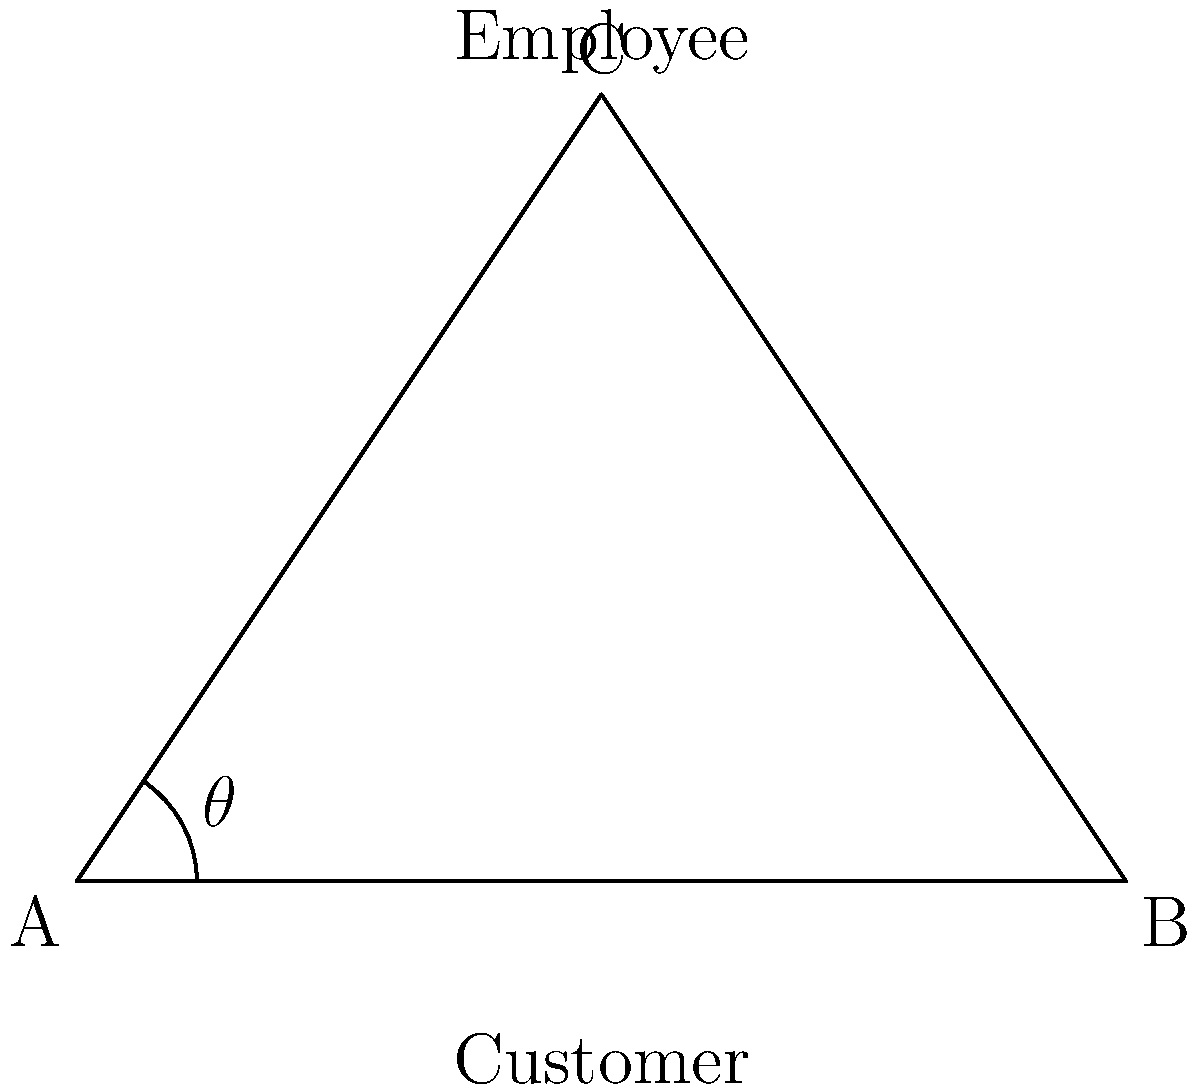In a customer interaction scenario, the angle of eye contact ($\theta$) between an employee and a customer is represented in the diagram. If the distance between the customer's eyes (AB) is 6 cm and the height of the employee's eyes from the customer's eye level (AC) is 9 cm, what is the angle of eye contact ($\theta$) to the nearest degree? To find the angle of eye contact ($\theta$), we can use the trigonometric function tangent. Let's approach this step-by-step:

1) In the right-angled triangle ABC, we know:
   - AB (opposite to $\theta$) = 6 cm
   - AC (adjacent to $\theta$) = 9 cm

2) The tangent of an angle is defined as the ratio of the opposite side to the adjacent side:

   $\tan(\theta) = \frac{\text{opposite}}{\text{adjacent}} = \frac{AB}{AC} = \frac{6}{9} = \frac{2}{3}$

3) To find $\theta$, we need to use the inverse tangent (arctangent) function:

   $\theta = \arctan(\frac{2}{3})$

4) Using a calculator or computer:

   $\theta \approx 33.69°$

5) Rounding to the nearest degree:

   $\theta \approx 34°$

Therefore, the angle of eye contact is approximately 34 degrees.
Answer: 34° 